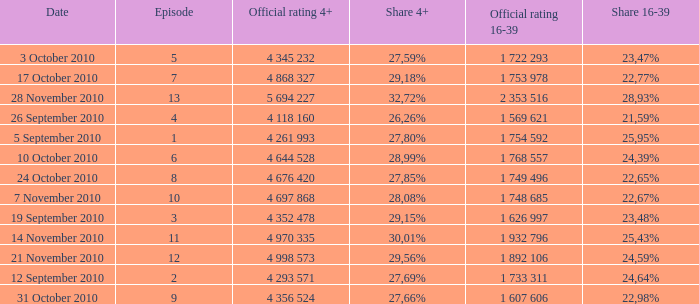What is the official rating 16-39 for the episode with  a 16-39 share of 22,77%? 1 753 978. 